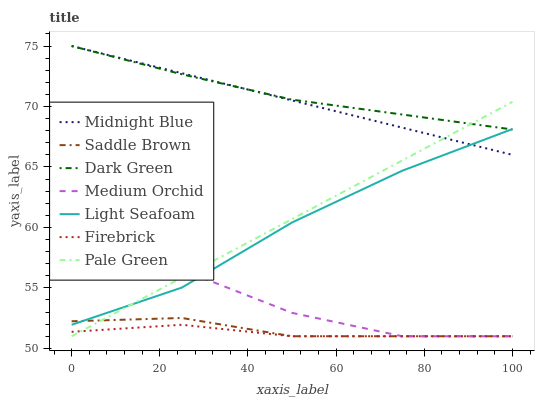Does Medium Orchid have the minimum area under the curve?
Answer yes or no. No. Does Medium Orchid have the maximum area under the curve?
Answer yes or no. No. Is Firebrick the smoothest?
Answer yes or no. No. Is Firebrick the roughest?
Answer yes or no. No. Does Light Seafoam have the lowest value?
Answer yes or no. No. Does Medium Orchid have the highest value?
Answer yes or no. No. Is Medium Orchid less than Midnight Blue?
Answer yes or no. Yes. Is Midnight Blue greater than Firebrick?
Answer yes or no. Yes. Does Medium Orchid intersect Midnight Blue?
Answer yes or no. No. 